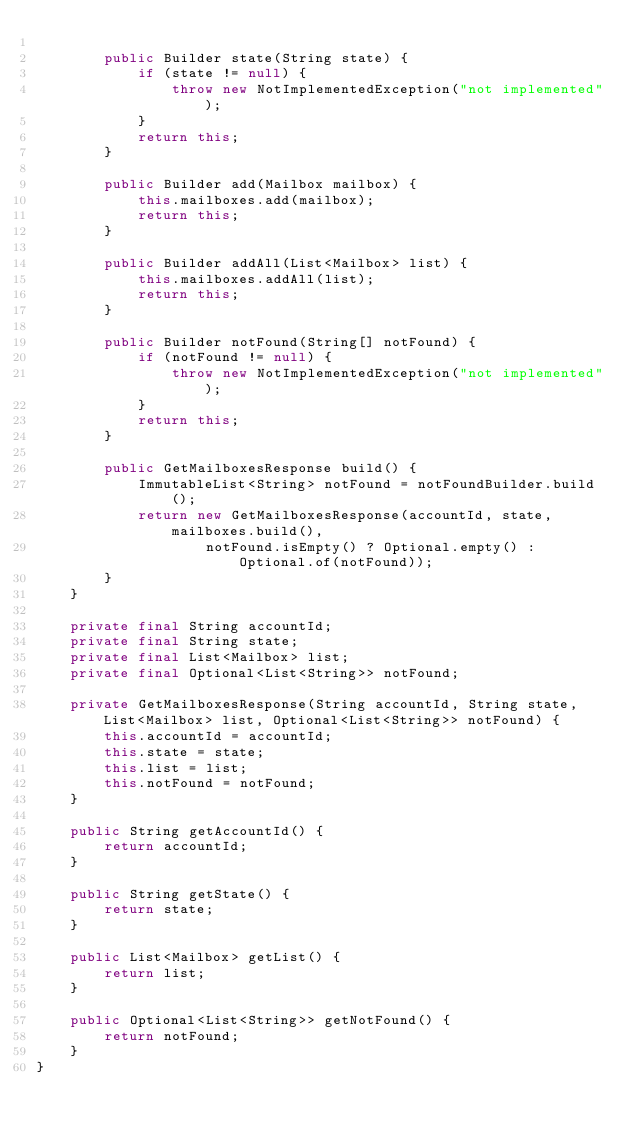<code> <loc_0><loc_0><loc_500><loc_500><_Java_>
        public Builder state(String state) {
            if (state != null) {
                throw new NotImplementedException("not implemented");
            }
            return this;
        }

        public Builder add(Mailbox mailbox) {
            this.mailboxes.add(mailbox);
            return this;
        }

        public Builder addAll(List<Mailbox> list) {
            this.mailboxes.addAll(list);
            return this;
        }
        
        public Builder notFound(String[] notFound) {
            if (notFound != null) {
                throw new NotImplementedException("not implemented");
            }
            return this;
        }

        public GetMailboxesResponse build() {
            ImmutableList<String> notFound = notFoundBuilder.build();
            return new GetMailboxesResponse(accountId, state, mailboxes.build(), 
                    notFound.isEmpty() ? Optional.empty() : Optional.of(notFound));
        }
    }

    private final String accountId;
    private final String state;
    private final List<Mailbox> list;
    private final Optional<List<String>> notFound;

    private GetMailboxesResponse(String accountId, String state, List<Mailbox> list, Optional<List<String>> notFound) {
        this.accountId = accountId;
        this.state = state;
        this.list = list;
        this.notFound = notFound;
    }

    public String getAccountId() {
        return accountId;
    }

    public String getState() {
        return state;
    }

    public List<Mailbox> getList() {
        return list;
    }

    public Optional<List<String>> getNotFound() {
        return notFound;
    }
}
</code> 